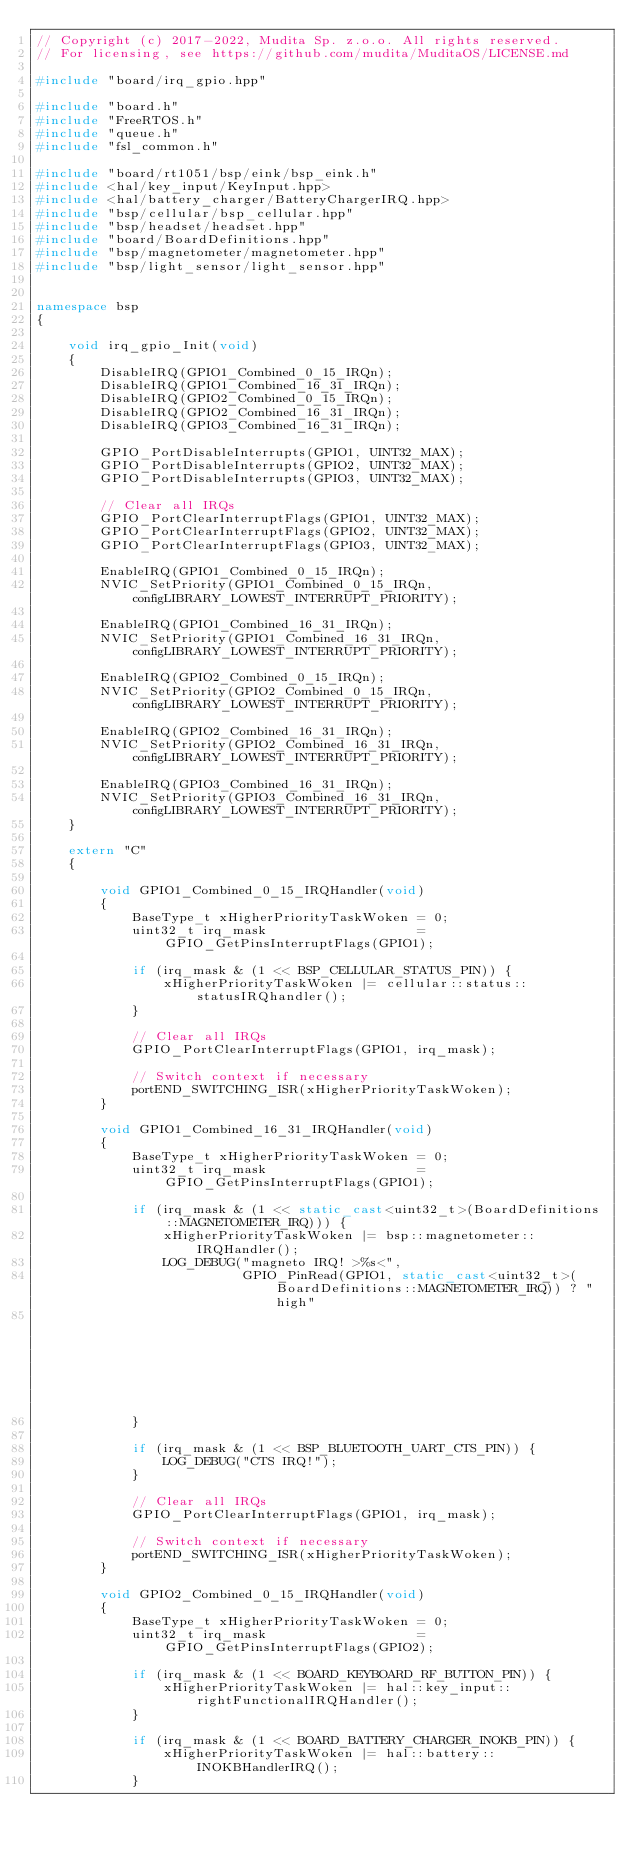<code> <loc_0><loc_0><loc_500><loc_500><_C++_>// Copyright (c) 2017-2022, Mudita Sp. z.o.o. All rights reserved.
// For licensing, see https://github.com/mudita/MuditaOS/LICENSE.md

#include "board/irq_gpio.hpp"

#include "board.h"
#include "FreeRTOS.h"
#include "queue.h"
#include "fsl_common.h"

#include "board/rt1051/bsp/eink/bsp_eink.h"
#include <hal/key_input/KeyInput.hpp>
#include <hal/battery_charger/BatteryChargerIRQ.hpp>
#include "bsp/cellular/bsp_cellular.hpp"
#include "bsp/headset/headset.hpp"
#include "board/BoardDefinitions.hpp"
#include "bsp/magnetometer/magnetometer.hpp"
#include "bsp/light_sensor/light_sensor.hpp"


namespace bsp
{

    void irq_gpio_Init(void)
    {
        DisableIRQ(GPIO1_Combined_0_15_IRQn);
        DisableIRQ(GPIO1_Combined_16_31_IRQn);
        DisableIRQ(GPIO2_Combined_0_15_IRQn);
        DisableIRQ(GPIO2_Combined_16_31_IRQn);
        DisableIRQ(GPIO3_Combined_16_31_IRQn);

        GPIO_PortDisableInterrupts(GPIO1, UINT32_MAX);
        GPIO_PortDisableInterrupts(GPIO2, UINT32_MAX);
        GPIO_PortDisableInterrupts(GPIO3, UINT32_MAX);

        // Clear all IRQs
        GPIO_PortClearInterruptFlags(GPIO1, UINT32_MAX);
        GPIO_PortClearInterruptFlags(GPIO2, UINT32_MAX);
        GPIO_PortClearInterruptFlags(GPIO3, UINT32_MAX);

        EnableIRQ(GPIO1_Combined_0_15_IRQn);
        NVIC_SetPriority(GPIO1_Combined_0_15_IRQn, configLIBRARY_LOWEST_INTERRUPT_PRIORITY);

        EnableIRQ(GPIO1_Combined_16_31_IRQn);
        NVIC_SetPriority(GPIO1_Combined_16_31_IRQn, configLIBRARY_LOWEST_INTERRUPT_PRIORITY);

        EnableIRQ(GPIO2_Combined_0_15_IRQn);
        NVIC_SetPriority(GPIO2_Combined_0_15_IRQn, configLIBRARY_LOWEST_INTERRUPT_PRIORITY);

        EnableIRQ(GPIO2_Combined_16_31_IRQn);
        NVIC_SetPriority(GPIO2_Combined_16_31_IRQn, configLIBRARY_LOWEST_INTERRUPT_PRIORITY);

        EnableIRQ(GPIO3_Combined_16_31_IRQn);
        NVIC_SetPriority(GPIO3_Combined_16_31_IRQn, configLIBRARY_LOWEST_INTERRUPT_PRIORITY);
    }

    extern "C"
    {

        void GPIO1_Combined_0_15_IRQHandler(void)
        {
            BaseType_t xHigherPriorityTaskWoken = 0;
            uint32_t irq_mask                   = GPIO_GetPinsInterruptFlags(GPIO1);

            if (irq_mask & (1 << BSP_CELLULAR_STATUS_PIN)) {
                xHigherPriorityTaskWoken |= cellular::status::statusIRQhandler();
            }

            // Clear all IRQs
            GPIO_PortClearInterruptFlags(GPIO1, irq_mask);

            // Switch context if necessary
            portEND_SWITCHING_ISR(xHigherPriorityTaskWoken);
        }

        void GPIO1_Combined_16_31_IRQHandler(void)
        {
            BaseType_t xHigherPriorityTaskWoken = 0;
            uint32_t irq_mask                   = GPIO_GetPinsInterruptFlags(GPIO1);

            if (irq_mask & (1 << static_cast<uint32_t>(BoardDefinitions::MAGNETOMETER_IRQ))) {
                xHigherPriorityTaskWoken |= bsp::magnetometer::IRQHandler();
                LOG_DEBUG("magneto IRQ! >%s<",
                          GPIO_PinRead(GPIO1, static_cast<uint32_t>(BoardDefinitions::MAGNETOMETER_IRQ)) ? "high"
                                                                                                         : "low");
            }

            if (irq_mask & (1 << BSP_BLUETOOTH_UART_CTS_PIN)) {
                LOG_DEBUG("CTS IRQ!");
            }

            // Clear all IRQs
            GPIO_PortClearInterruptFlags(GPIO1, irq_mask);

            // Switch context if necessary
            portEND_SWITCHING_ISR(xHigherPriorityTaskWoken);
        }

        void GPIO2_Combined_0_15_IRQHandler(void)
        {
            BaseType_t xHigherPriorityTaskWoken = 0;
            uint32_t irq_mask                   = GPIO_GetPinsInterruptFlags(GPIO2);

            if (irq_mask & (1 << BOARD_KEYBOARD_RF_BUTTON_PIN)) {
                xHigherPriorityTaskWoken |= hal::key_input::rightFunctionalIRQHandler();
            }

            if (irq_mask & (1 << BOARD_BATTERY_CHARGER_INOKB_PIN)) {
                xHigherPriorityTaskWoken |= hal::battery::INOKBHandlerIRQ();
            }
</code> 